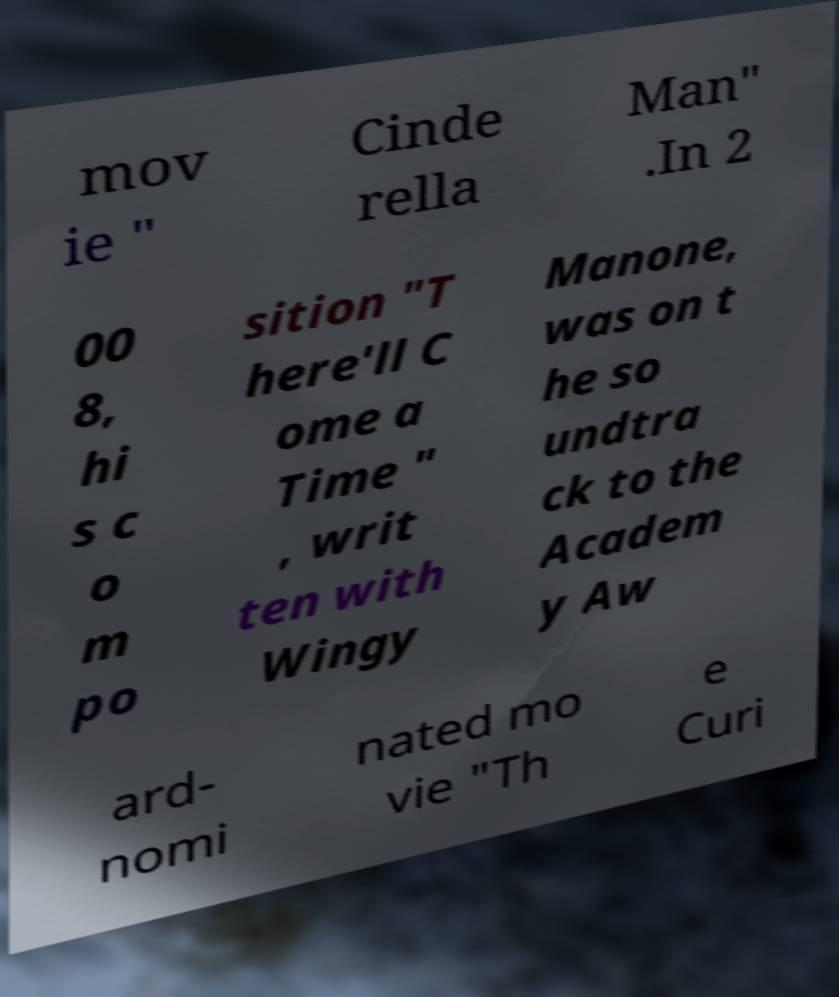Could you extract and type out the text from this image? mov ie " Cinde rella Man" .In 2 00 8, hi s c o m po sition "T here'll C ome a Time " , writ ten with Wingy Manone, was on t he so undtra ck to the Academ y Aw ard- nomi nated mo vie "Th e Curi 